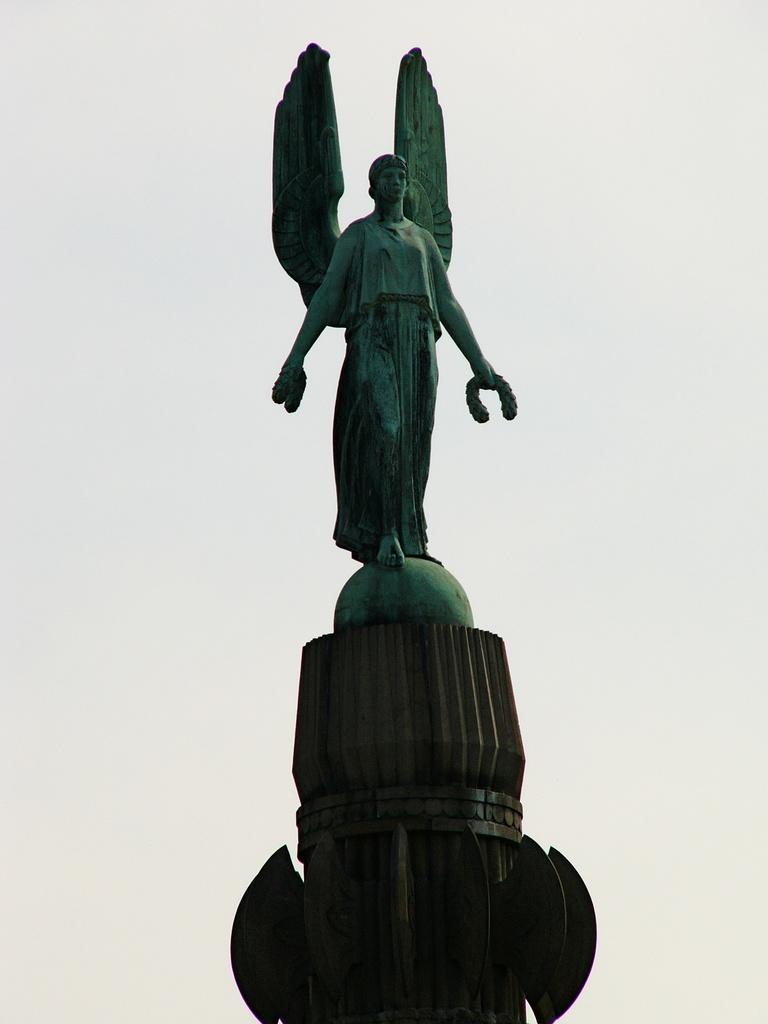What is the main subject in the center of the image? There is a statue in the center of the image. What color is the balloon held by the stranger in the image? There is no stranger or balloon present in the image; it only features a statue. 